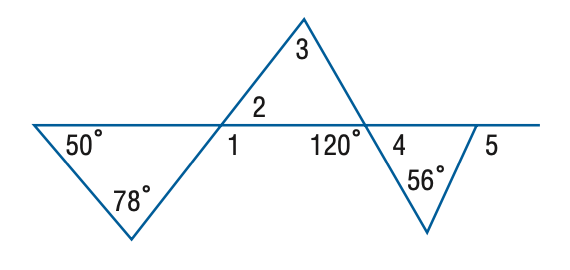Answer the mathemtical geometry problem and directly provide the correct option letter.
Question: Find the measure of \angle 2 in the figure.
Choices: A: 50 B: 52 C: 56 D: 60 B 